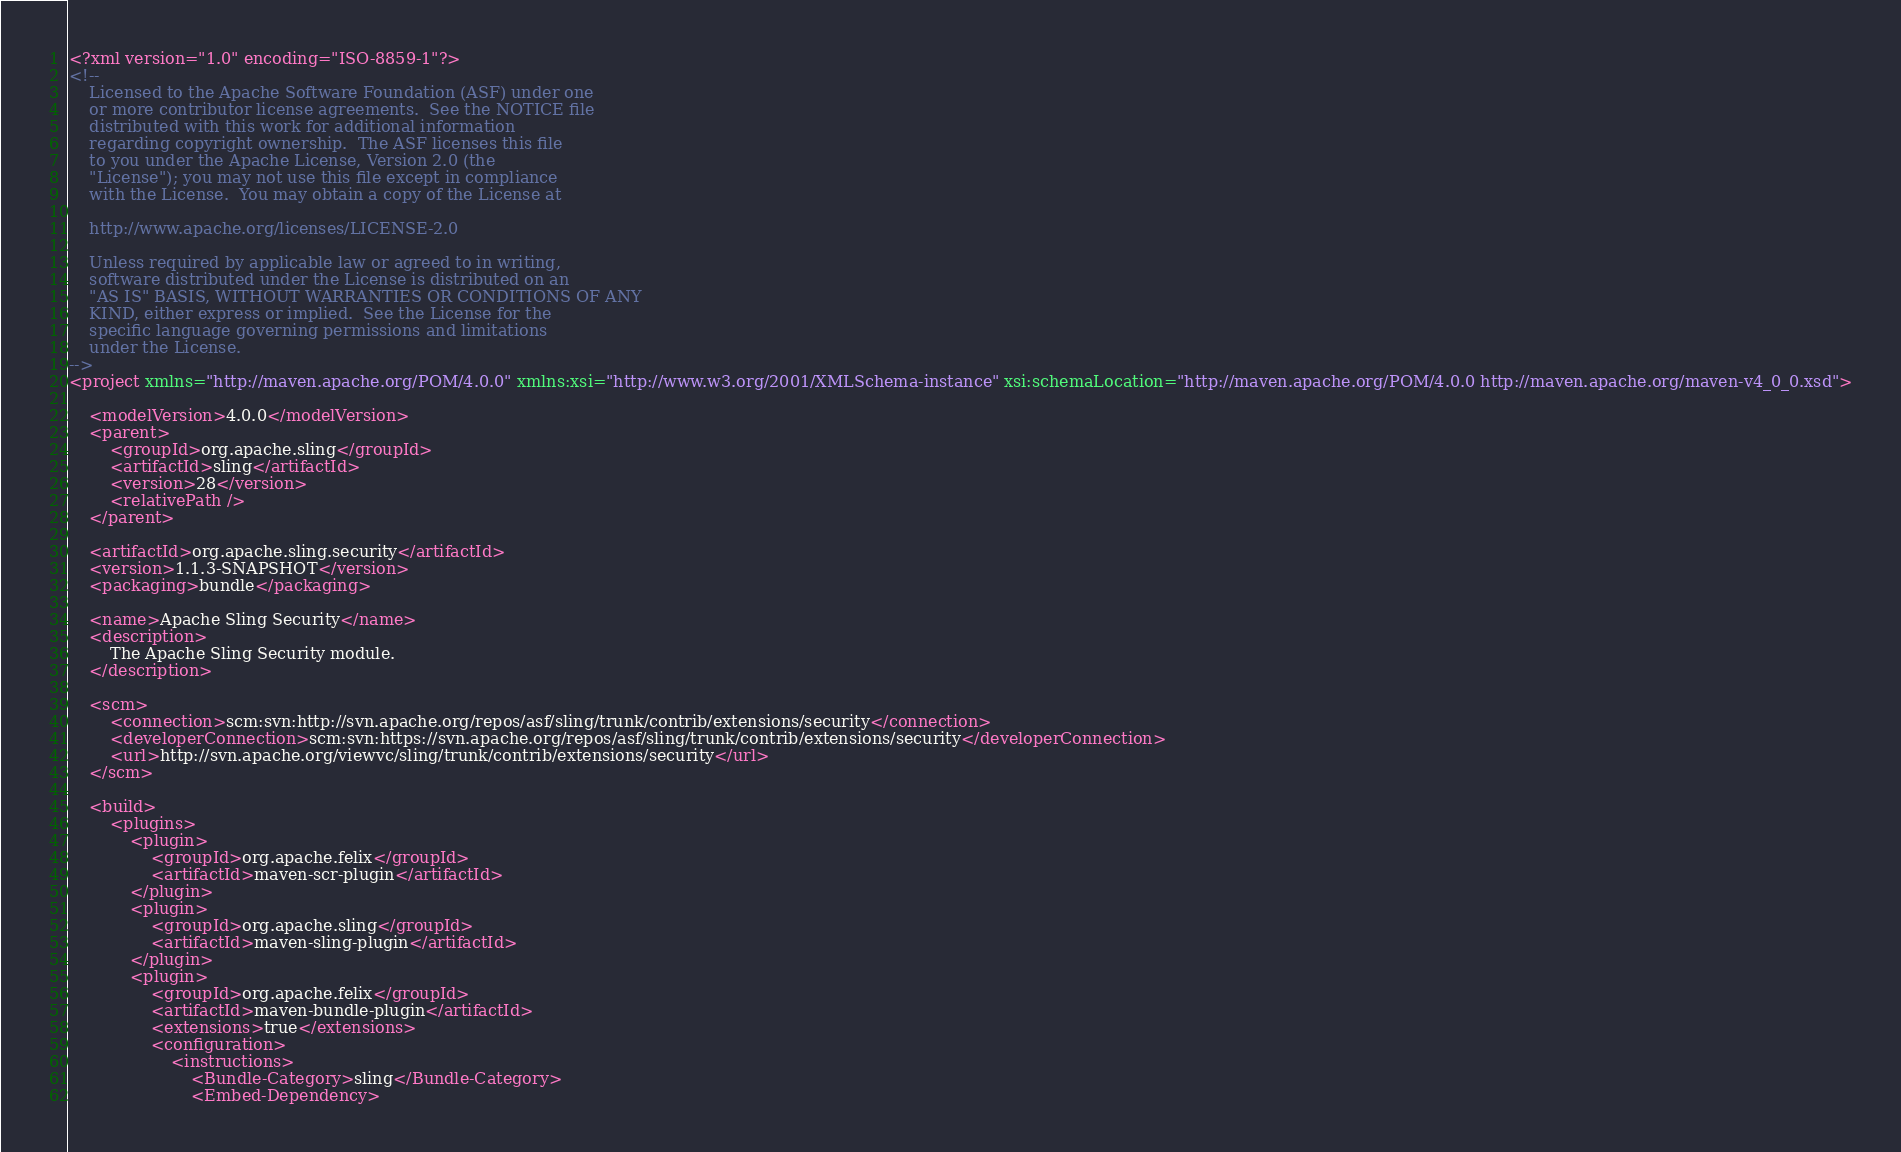<code> <loc_0><loc_0><loc_500><loc_500><_XML_><?xml version="1.0" encoding="ISO-8859-1"?>
<!--
    Licensed to the Apache Software Foundation (ASF) under one
    or more contributor license agreements.  See the NOTICE file
    distributed with this work for additional information
    regarding copyright ownership.  The ASF licenses this file
    to you under the Apache License, Version 2.0 (the
    "License"); you may not use this file except in compliance
    with the License.  You may obtain a copy of the License at
    
    http://www.apache.org/licenses/LICENSE-2.0
    
    Unless required by applicable law or agreed to in writing,
    software distributed under the License is distributed on an
    "AS IS" BASIS, WITHOUT WARRANTIES OR CONDITIONS OF ANY
    KIND, either express or implied.  See the License for the
    specific language governing permissions and limitations
    under the License.
-->
<project xmlns="http://maven.apache.org/POM/4.0.0" xmlns:xsi="http://www.w3.org/2001/XMLSchema-instance" xsi:schemaLocation="http://maven.apache.org/POM/4.0.0 http://maven.apache.org/maven-v4_0_0.xsd">

    <modelVersion>4.0.0</modelVersion>
    <parent>
        <groupId>org.apache.sling</groupId>
        <artifactId>sling</artifactId>
        <version>28</version>
        <relativePath />
    </parent>

    <artifactId>org.apache.sling.security</artifactId>
    <version>1.1.3-SNAPSHOT</version>
    <packaging>bundle</packaging>

    <name>Apache Sling Security</name>
    <description>
        The Apache Sling Security module.
    </description>

    <scm>
        <connection>scm:svn:http://svn.apache.org/repos/asf/sling/trunk/contrib/extensions/security</connection>
        <developerConnection>scm:svn:https://svn.apache.org/repos/asf/sling/trunk/contrib/extensions/security</developerConnection>
        <url>http://svn.apache.org/viewvc/sling/trunk/contrib/extensions/security</url>
    </scm>

    <build>
        <plugins>
            <plugin>
                <groupId>org.apache.felix</groupId>
                <artifactId>maven-scr-plugin</artifactId>
            </plugin>
            <plugin>
                <groupId>org.apache.sling</groupId>
                <artifactId>maven-sling-plugin</artifactId>
            </plugin>
            <plugin>
                <groupId>org.apache.felix</groupId>
                <artifactId>maven-bundle-plugin</artifactId>
                <extensions>true</extensions>
                <configuration>
                    <instructions>
                        <Bundle-Category>sling</Bundle-Category>
                        <Embed-Dependency></code> 